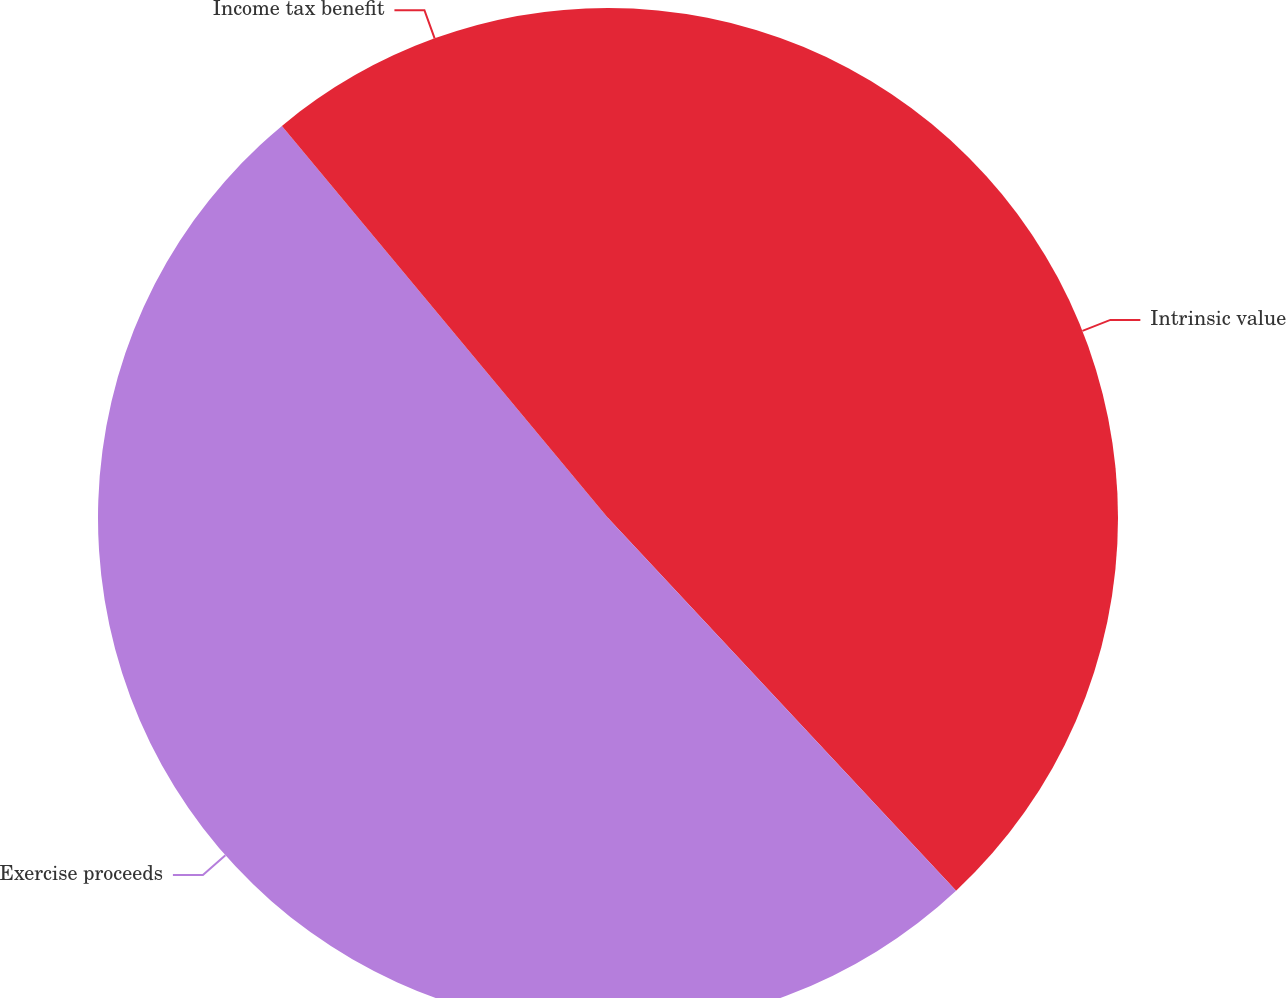Convert chart. <chart><loc_0><loc_0><loc_500><loc_500><pie_chart><fcel>Intrinsic value<fcel>Exercise proceeds<fcel>Income tax benefit<nl><fcel>38.04%<fcel>50.91%<fcel>11.04%<nl></chart> 